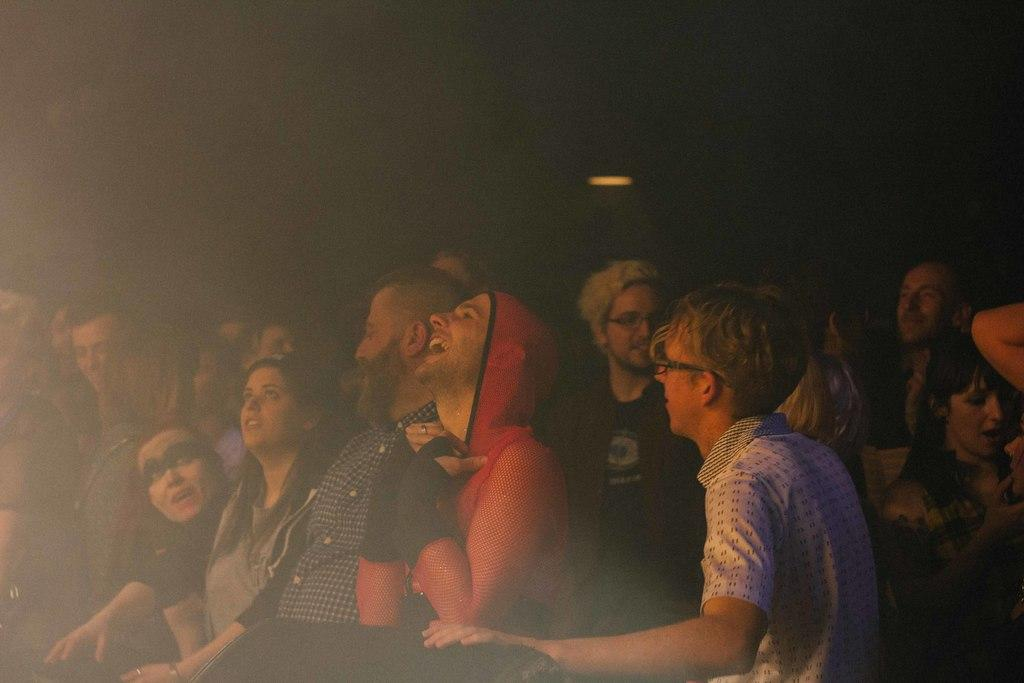How many people are in the image? There is a group of people in the image, but the exact number is not specified. What can be observed about the background of the image? The background of the image is dark. What type of rock is being played by the group of people in the image? There is no rock or any musical instrument visible in the image; it only shows a group of people with a dark background. 